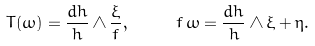<formula> <loc_0><loc_0><loc_500><loc_500>T ( \omega ) = \frac { d h } { h } \wedge \frac { \xi } { f } , \quad \ f \, \omega = \frac { d h } { h } \wedge \xi + \eta .</formula> 